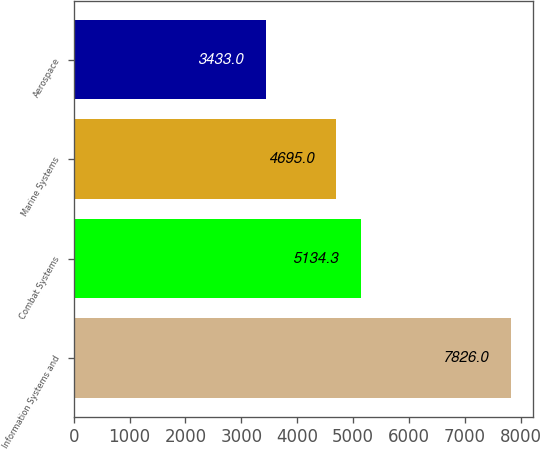<chart> <loc_0><loc_0><loc_500><loc_500><bar_chart><fcel>Information Systems and<fcel>Combat Systems<fcel>Marine Systems<fcel>Aerospace<nl><fcel>7826<fcel>5134.3<fcel>4695<fcel>3433<nl></chart> 